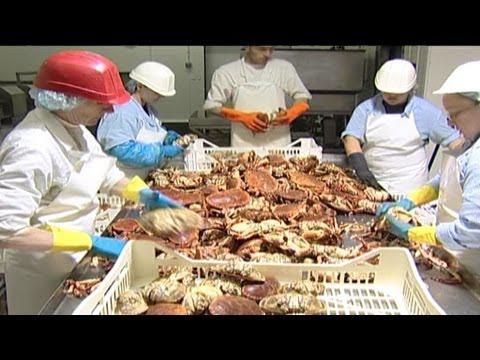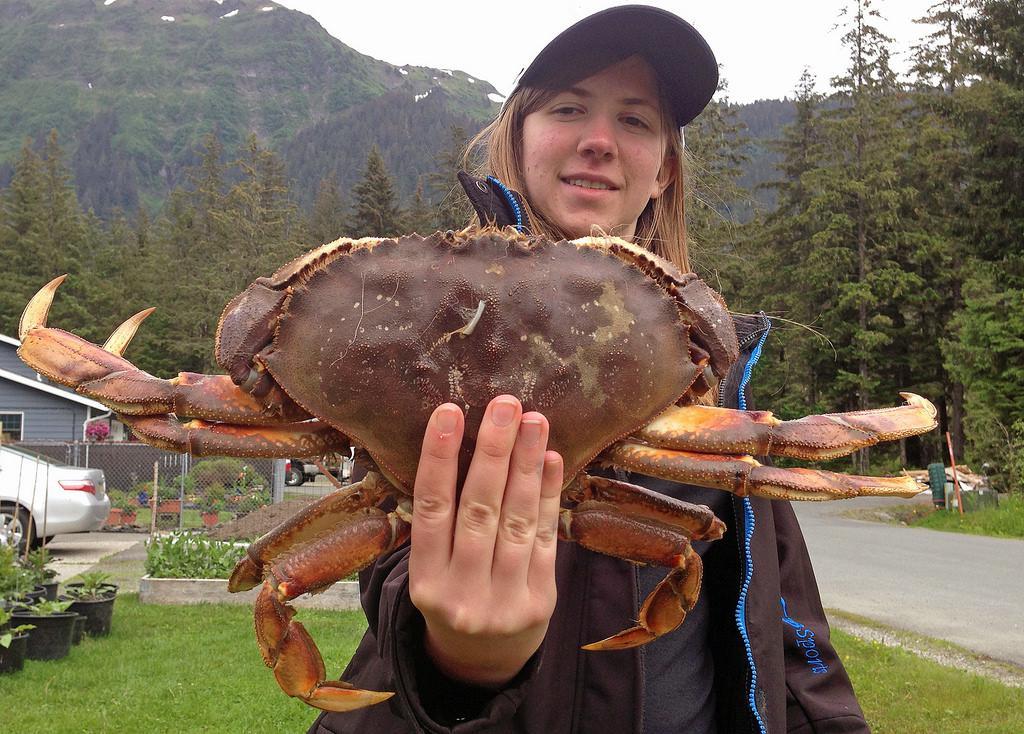The first image is the image on the left, the second image is the image on the right. Considering the images on both sides, is "In one image, a person wearing a front-brimmed hat and jacket is holding a single large crab with its legs outstretched." valid? Answer yes or no. Yes. The first image is the image on the left, the second image is the image on the right. Examine the images to the left and right. Is the description "The right image features a person in a ball cap holding up a purple crab with the bare hand of the arm on the left." accurate? Answer yes or no. Yes. 